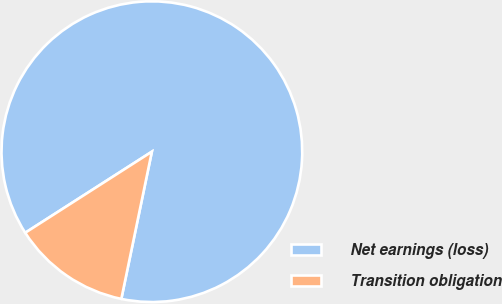Convert chart to OTSL. <chart><loc_0><loc_0><loc_500><loc_500><pie_chart><fcel>Net earnings (loss)<fcel>Transition obligation<nl><fcel>87.32%<fcel>12.68%<nl></chart> 